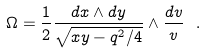Convert formula to latex. <formula><loc_0><loc_0><loc_500><loc_500>\Omega = \frac { 1 } { 2 } \frac { d x \wedge d y } { \sqrt { x y - q ^ { 2 } / 4 } } \wedge \frac { d v } { v } \ .</formula> 